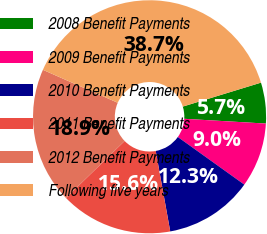Convert chart to OTSL. <chart><loc_0><loc_0><loc_500><loc_500><pie_chart><fcel>2008 Benefit Payments<fcel>2009 Benefit Payments<fcel>2010 Benefit Payments<fcel>2011 Benefit Payments<fcel>2012 Benefit Payments<fcel>Following five years<nl><fcel>5.66%<fcel>8.96%<fcel>12.27%<fcel>15.57%<fcel>18.87%<fcel>38.67%<nl></chart> 